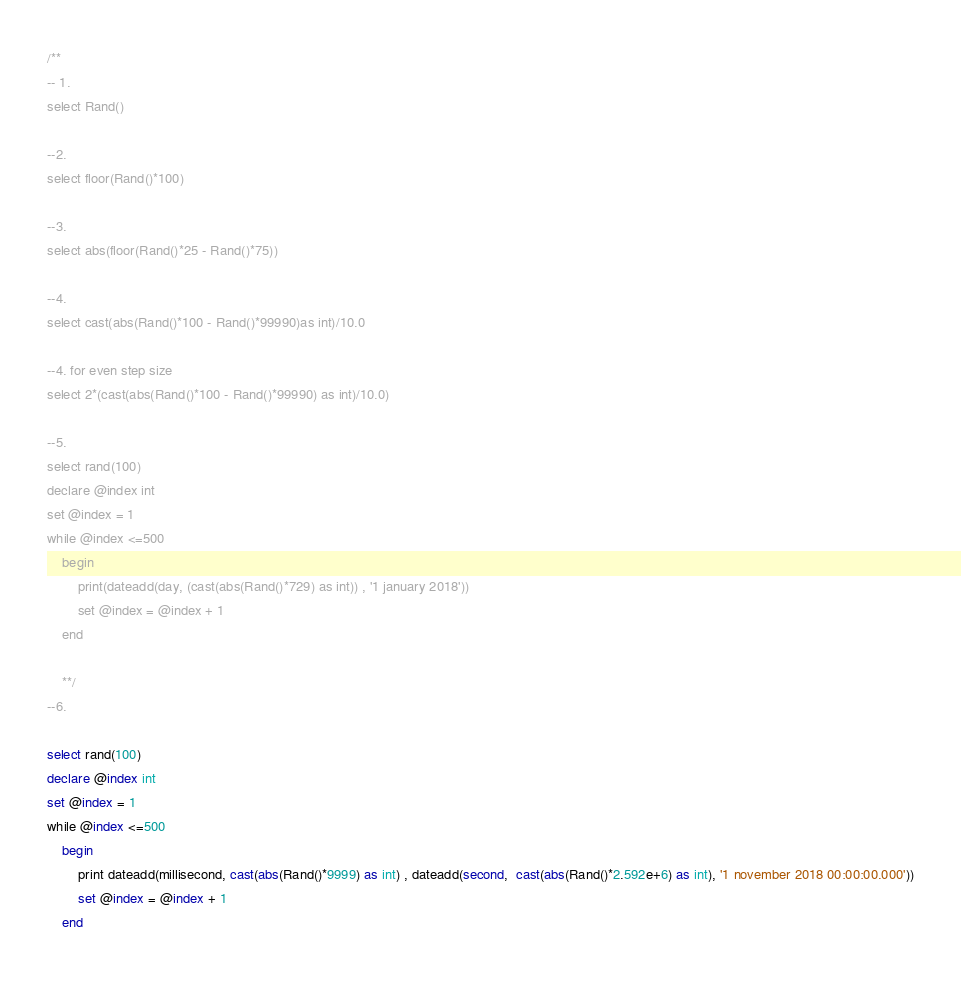<code> <loc_0><loc_0><loc_500><loc_500><_SQL_>/**
-- 1.
select Rand()

--2.
select floor(Rand()*100)

--3.
select abs(floor(Rand()*25 - Rand()*75))

--4.
select cast(abs(Rand()*100 - Rand()*99990)as int)/10.0

--4. for even step size
select 2*(cast(abs(Rand()*100 - Rand()*99990) as int)/10.0)

--5.
select rand(100)
declare @index int
set @index = 1
while @index <=500
	begin
		print(dateadd(day, (cast(abs(Rand()*729) as int)) , '1 january 2018'))
		set @index = @index + 1
	end

	**/
--6.

select rand(100)
declare @index int
set @index = 1
while @index <=500
	begin
		print dateadd(millisecond, cast(abs(Rand()*9999) as int) , dateadd(second,  cast(abs(Rand()*2.592e+6) as int), '1 november 2018 00:00:00.000'))
		set @index = @index + 1
	end


</code> 